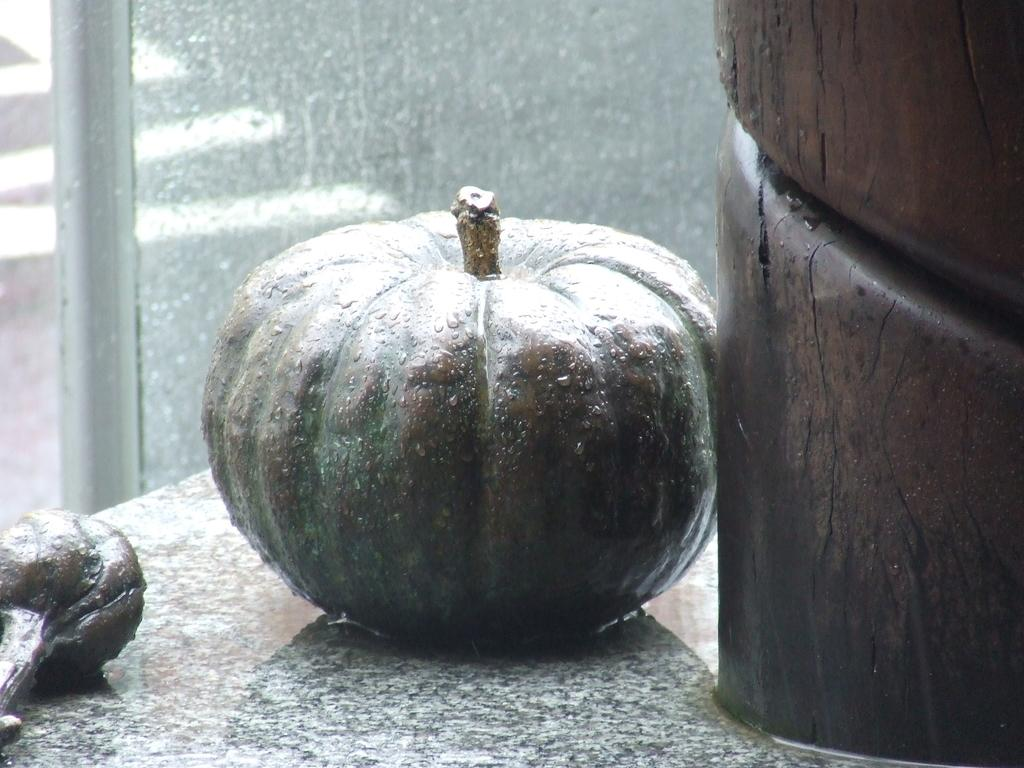What is the main object in the middle of the image? There is a pumpkin in the middle of the image. What type of wall can be seen at the back side of the image? There is a glass wall at the back side of the image. What type of current can be seen flowing through the pumpkin in the image? There is no current flowing through the pumpkin in the image, as it is a stationary object. 